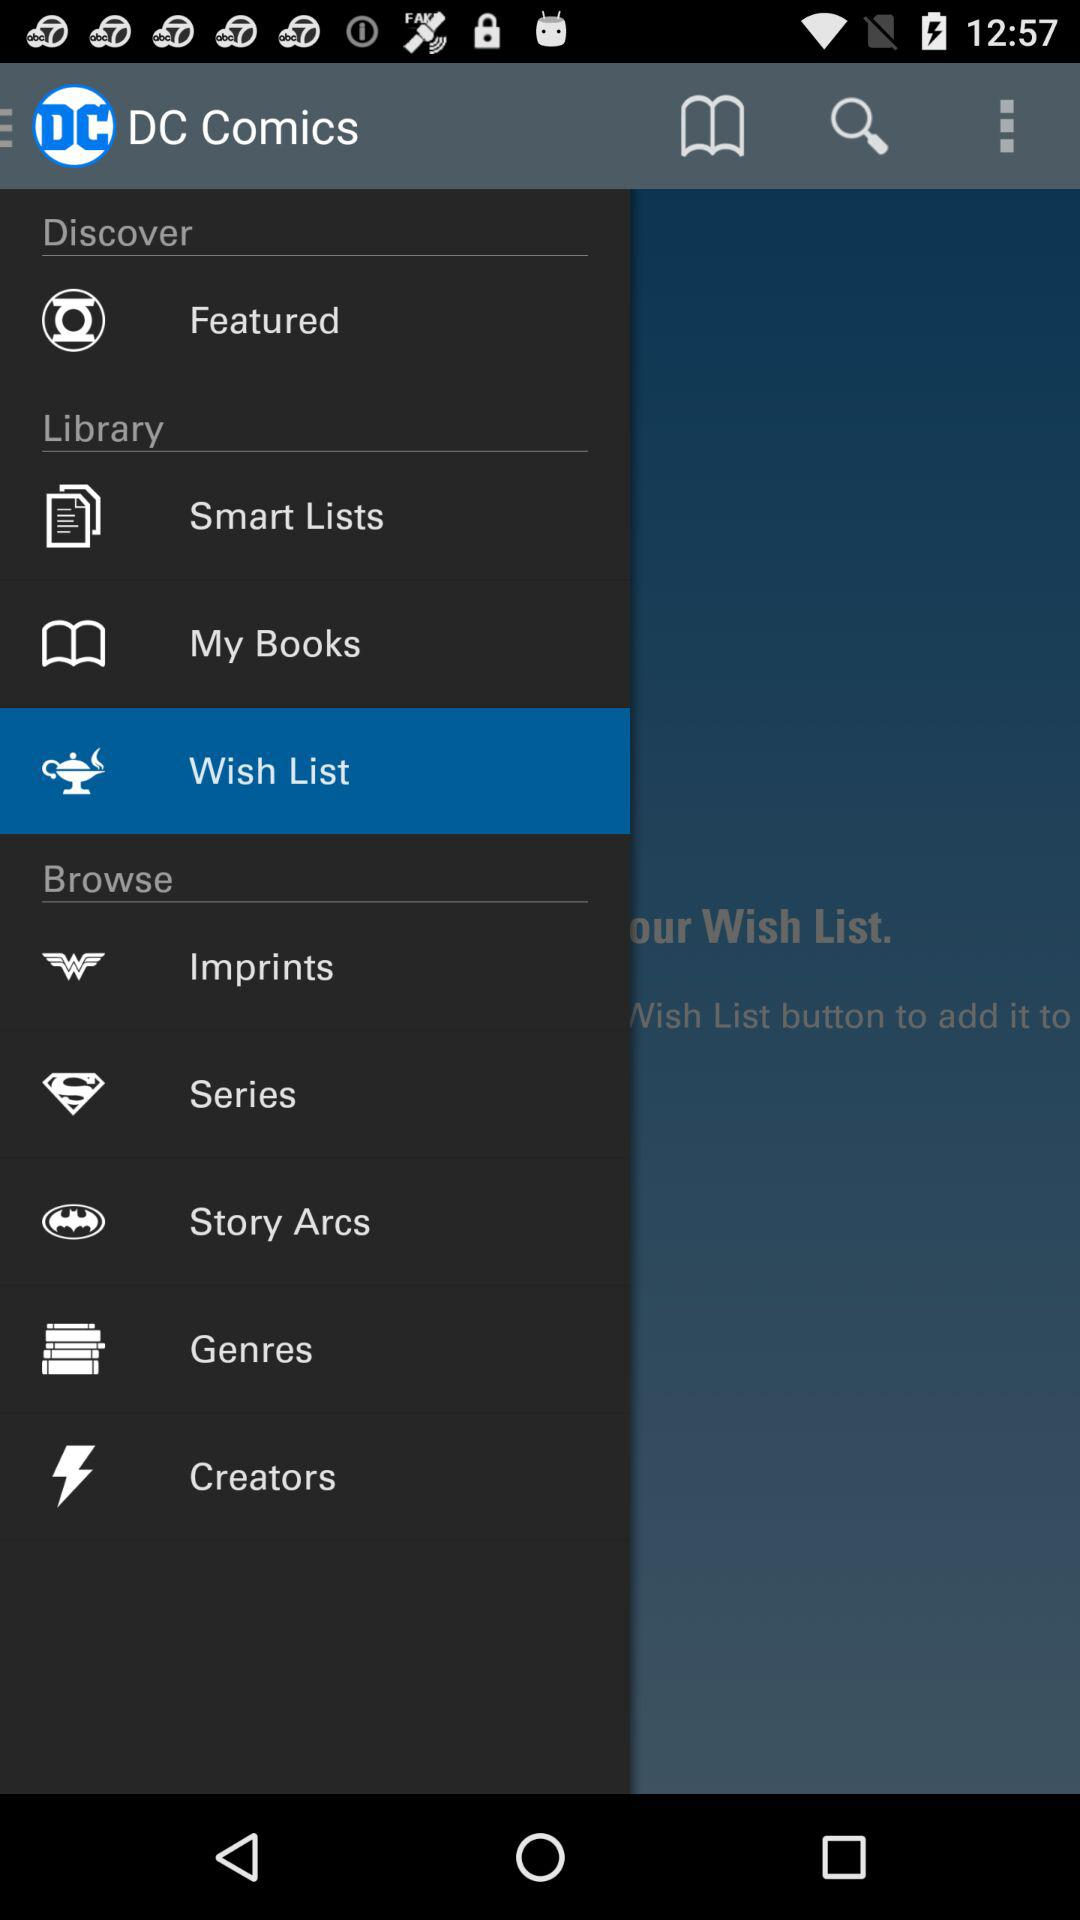What is the name of the application? The name of the application is "DC Comics". 